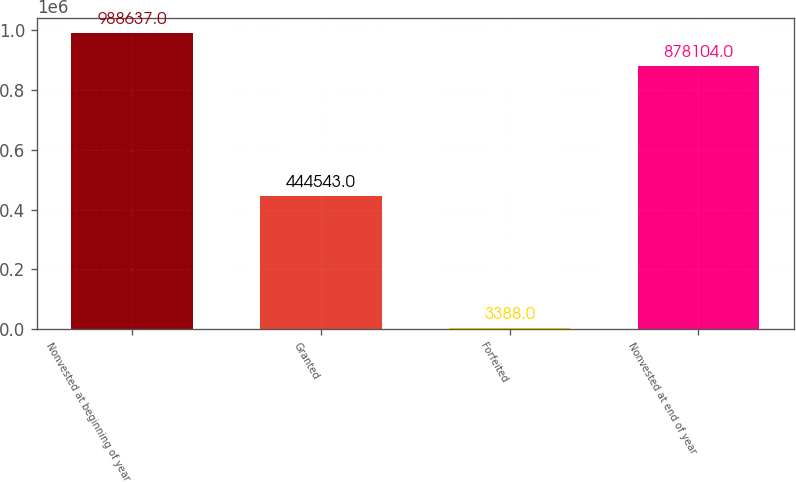Convert chart to OTSL. <chart><loc_0><loc_0><loc_500><loc_500><bar_chart><fcel>Nonvested at beginning of year<fcel>Granted<fcel>Forfeited<fcel>Nonvested at end of year<nl><fcel>988637<fcel>444543<fcel>3388<fcel>878104<nl></chart> 